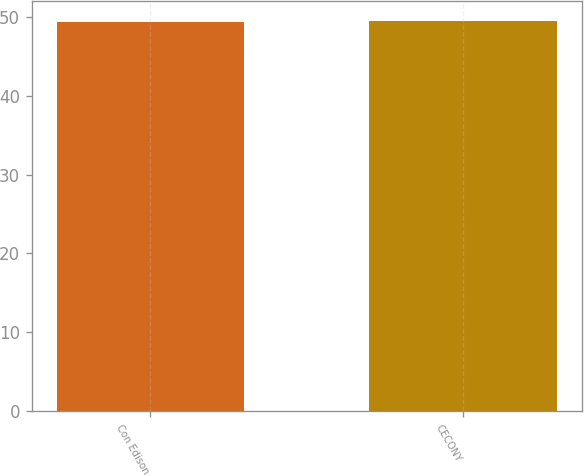<chart> <loc_0><loc_0><loc_500><loc_500><bar_chart><fcel>Con Edison<fcel>CECONY<nl><fcel>49.3<fcel>49.5<nl></chart> 